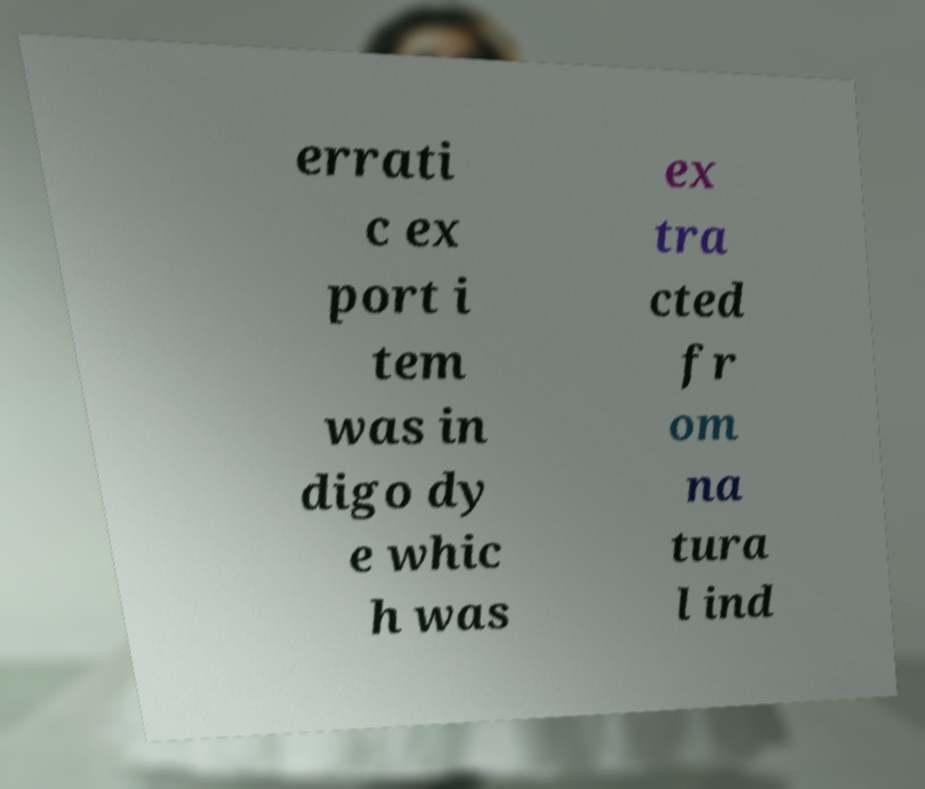For documentation purposes, I need the text within this image transcribed. Could you provide that? errati c ex port i tem was in digo dy e whic h was ex tra cted fr om na tura l ind 